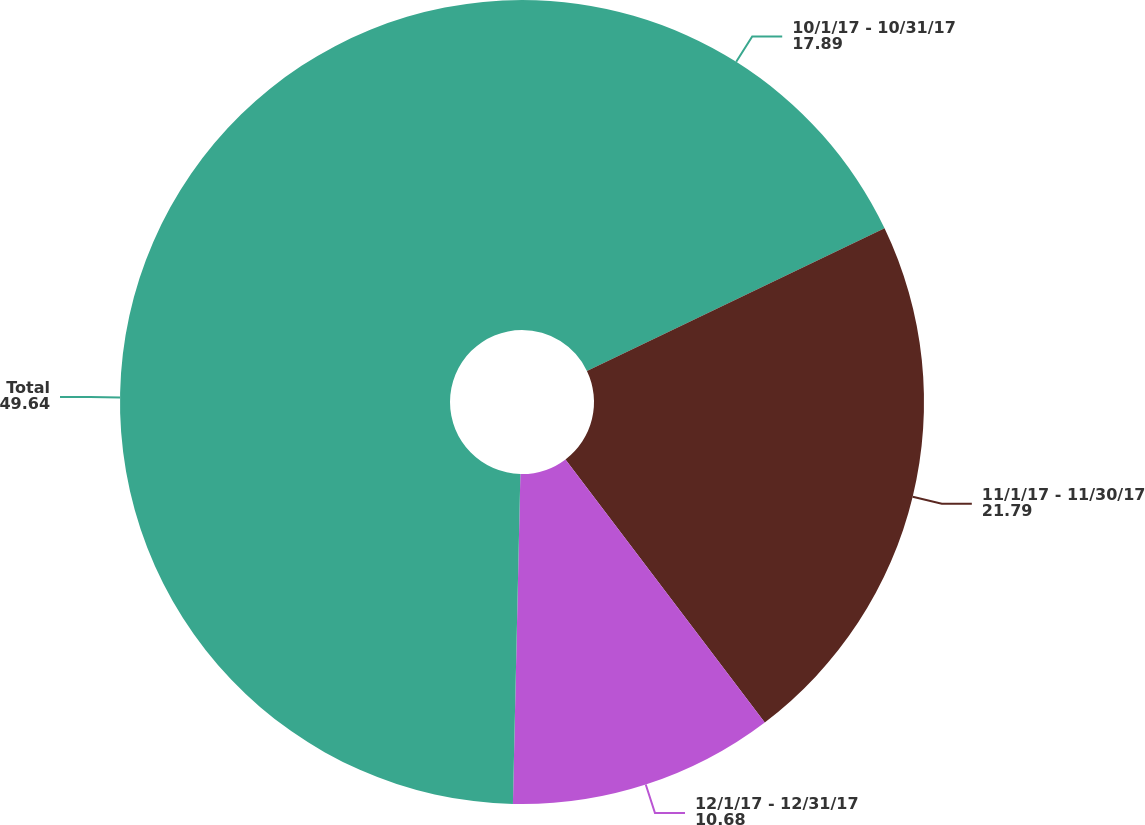Convert chart. <chart><loc_0><loc_0><loc_500><loc_500><pie_chart><fcel>10/1/17 - 10/31/17<fcel>11/1/17 - 11/30/17<fcel>12/1/17 - 12/31/17<fcel>Total<nl><fcel>17.89%<fcel>21.79%<fcel>10.68%<fcel>49.64%<nl></chart> 